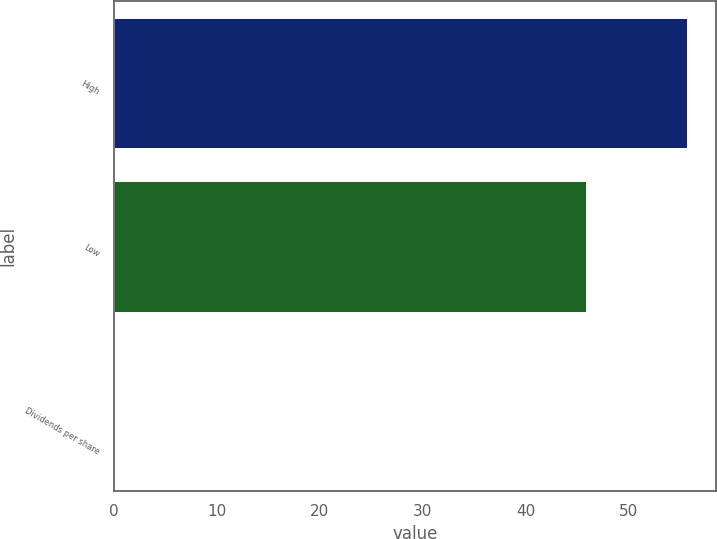Convert chart. <chart><loc_0><loc_0><loc_500><loc_500><bar_chart><fcel>High<fcel>Low<fcel>Dividends per share<nl><fcel>55.75<fcel>45.85<fcel>0.1<nl></chart> 